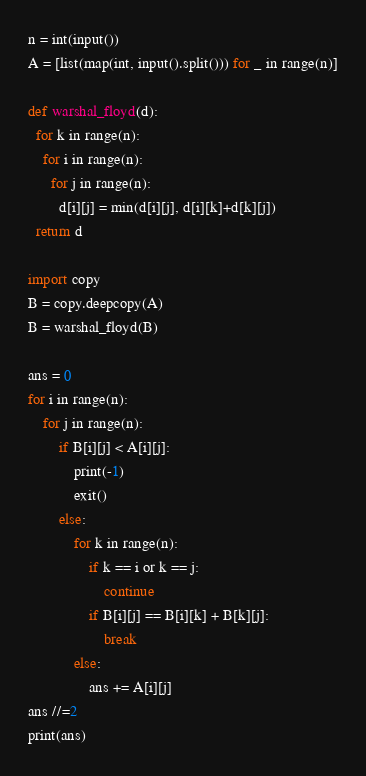<code> <loc_0><loc_0><loc_500><loc_500><_Python_>n = int(input())
A = [list(map(int, input().split())) for _ in range(n)]

def warshal_floyd(d):
  for k in range(n):
    for i in range(n):
      for j in range(n):
        d[i][j] = min(d[i][j], d[i][k]+d[k][j])
  return d

import copy
B = copy.deepcopy(A)
B = warshal_floyd(B)

ans = 0
for i in range(n):
    for j in range(n):
        if B[i][j] < A[i][j]:
            print(-1)
            exit()
        else:
            for k in range(n):
                if k == i or k == j:
                    continue
                if B[i][j] == B[i][k] + B[k][j]:
                    break
            else:
                ans += A[i][j]
ans //=2
print(ans)</code> 